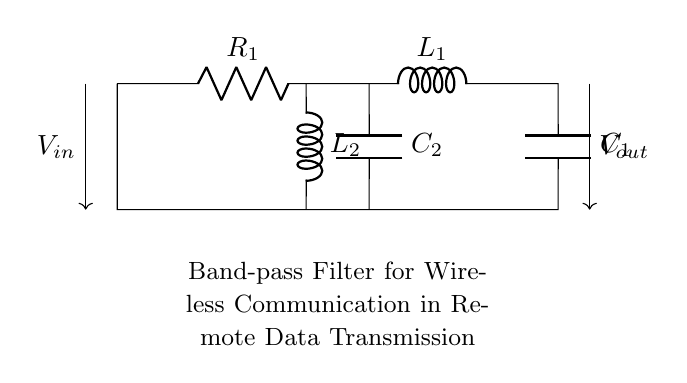What type of filter is shown in the circuit? The circuit is labeled as a band-pass filter, which allows signals within a certain frequency range to pass while attenuating signals outside that range.
Answer: band-pass filter How many reactive components are present in this circuit? The circuit includes two inductors and two capacitors, making a total of four reactive components.
Answer: four What is the purpose of the inductors in this circuit? Inductors in a band-pass filter are used to block high-frequency and low-frequency signals; they contribute to the filtering effect.
Answer: filtering What are the voltage input and output characteristics of this filter? The filter receives an input voltage and accordingly outputs a specific voltage that corresponds to the allowed frequencies, although precise values aren't shown.
Answer: variable What is the relationship between R1 and the overall filter response? Resistor R1 impacts the damping of the filter, affecting the sharpness of the frequency response; higher resistance typically leads to more damping and a smoother curve.
Answer: damping effect What role do the capacitors play in this filter design? Capacitors in this filter allow certain frequency signals to pass while blocking others, working with inductors to set the bandwidth of the filter.
Answer: band-setting What frequency range does this band-pass filter operate within? The circuit does not specify exact frequencies; however, the design is intended for specific frequency ranges required for wireless communication applications.
Answer: specific range 